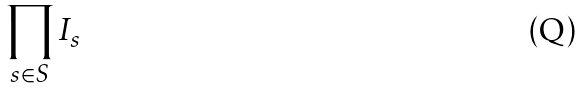Convert formula to latex. <formula><loc_0><loc_0><loc_500><loc_500>\prod _ { s \in S } I _ { s }</formula> 